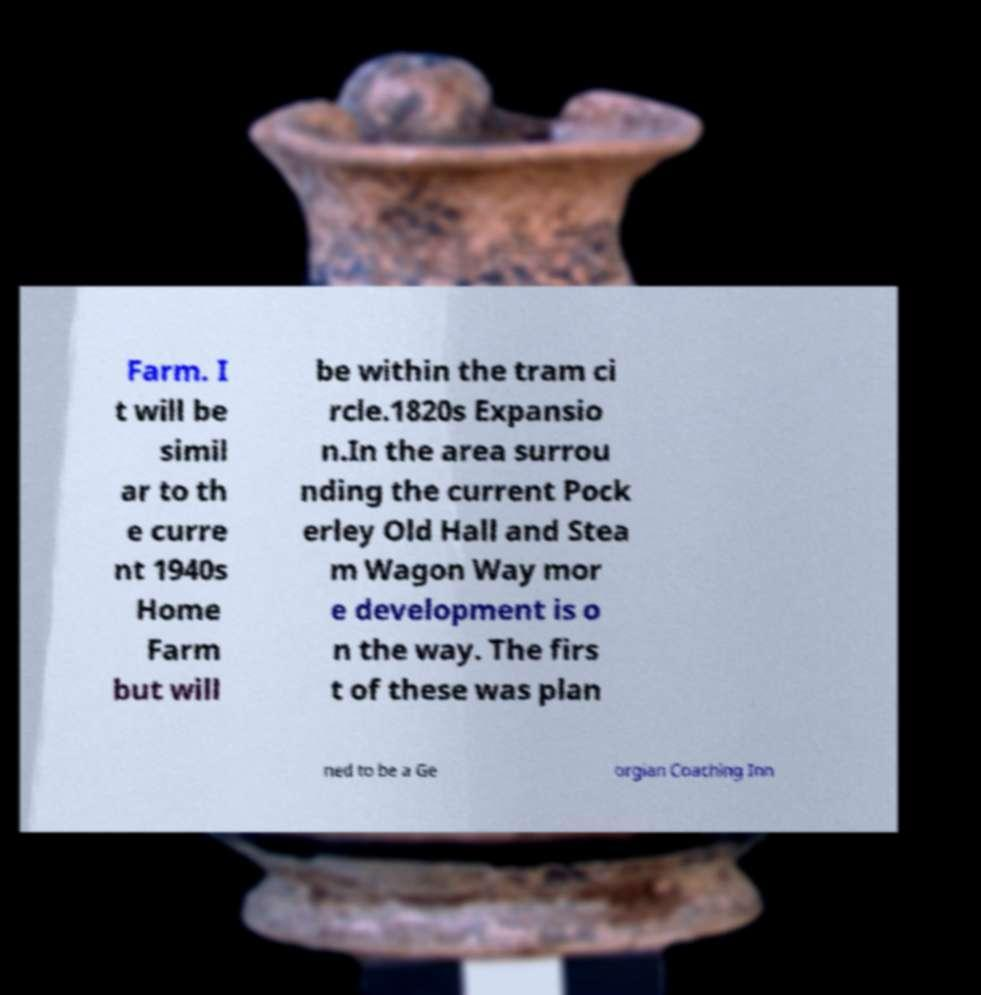For documentation purposes, I need the text within this image transcribed. Could you provide that? Farm. I t will be simil ar to th e curre nt 1940s Home Farm but will be within the tram ci rcle.1820s Expansio n.In the area surrou nding the current Pock erley Old Hall and Stea m Wagon Way mor e development is o n the way. The firs t of these was plan ned to be a Ge orgian Coaching Inn 